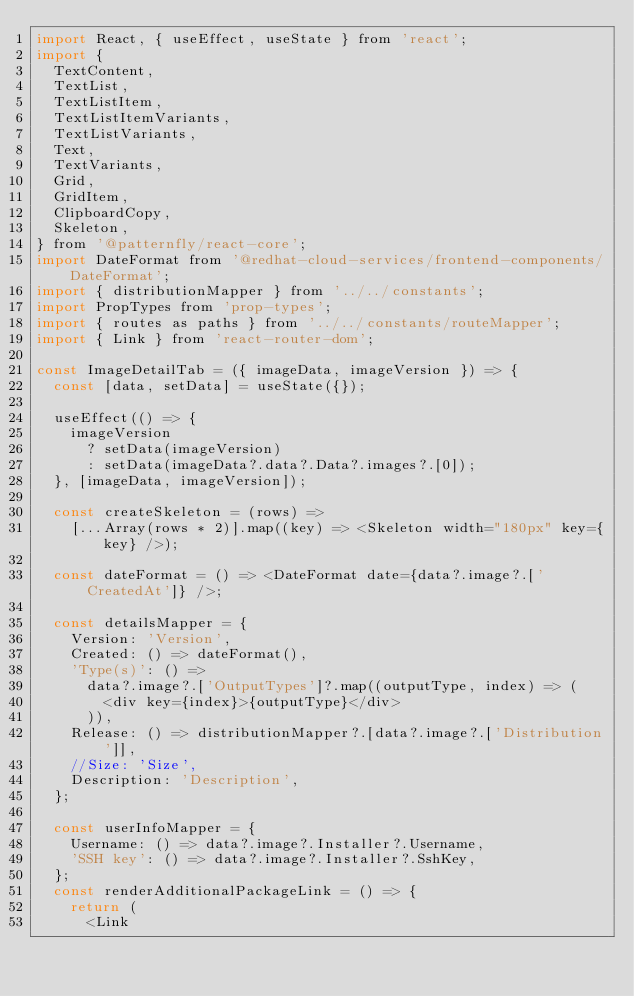Convert code to text. <code><loc_0><loc_0><loc_500><loc_500><_JavaScript_>import React, { useEffect, useState } from 'react';
import {
  TextContent,
  TextList,
  TextListItem,
  TextListItemVariants,
  TextListVariants,
  Text,
  TextVariants,
  Grid,
  GridItem,
  ClipboardCopy,
  Skeleton,
} from '@patternfly/react-core';
import DateFormat from '@redhat-cloud-services/frontend-components/DateFormat';
import { distributionMapper } from '../../constants';
import PropTypes from 'prop-types';
import { routes as paths } from '../../constants/routeMapper';
import { Link } from 'react-router-dom';

const ImageDetailTab = ({ imageData, imageVersion }) => {
  const [data, setData] = useState({});

  useEffect(() => {
    imageVersion
      ? setData(imageVersion)
      : setData(imageData?.data?.Data?.images?.[0]);
  }, [imageData, imageVersion]);

  const createSkeleton = (rows) =>
    [...Array(rows * 2)].map((key) => <Skeleton width="180px" key={key} />);

  const dateFormat = () => <DateFormat date={data?.image?.['CreatedAt']} />;

  const detailsMapper = {
    Version: 'Version',
    Created: () => dateFormat(),
    'Type(s)': () =>
      data?.image?.['OutputTypes']?.map((outputType, index) => (
        <div key={index}>{outputType}</div>
      )),
    Release: () => distributionMapper?.[data?.image?.['Distribution']],
    //Size: 'Size',
    Description: 'Description',
  };

  const userInfoMapper = {
    Username: () => data?.image?.Installer?.Username,
    'SSH key': () => data?.image?.Installer?.SshKey,
  };
  const renderAdditionalPackageLink = () => {
    return (
      <Link</code> 